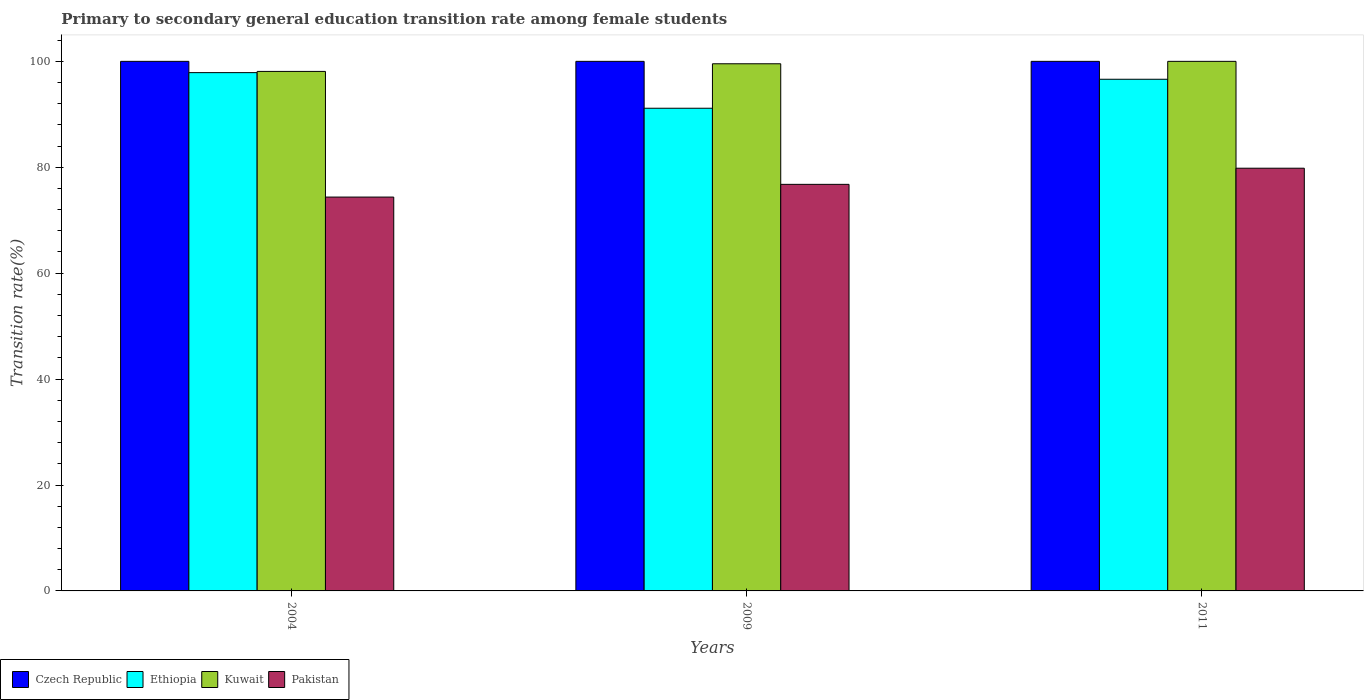How many groups of bars are there?
Keep it short and to the point. 3. Are the number of bars per tick equal to the number of legend labels?
Make the answer very short. Yes. Are the number of bars on each tick of the X-axis equal?
Provide a succinct answer. Yes. How many bars are there on the 1st tick from the left?
Keep it short and to the point. 4. How many bars are there on the 1st tick from the right?
Offer a terse response. 4. What is the label of the 1st group of bars from the left?
Offer a very short reply. 2004. What is the transition rate in Kuwait in 2004?
Ensure brevity in your answer.  98.1. Across all years, what is the maximum transition rate in Czech Republic?
Your response must be concise. 100. Across all years, what is the minimum transition rate in Ethiopia?
Your answer should be very brief. 91.15. In which year was the transition rate in Pakistan maximum?
Provide a succinct answer. 2011. In which year was the transition rate in Czech Republic minimum?
Offer a very short reply. 2004. What is the total transition rate in Pakistan in the graph?
Make the answer very short. 230.97. What is the difference between the transition rate in Ethiopia in 2004 and that in 2009?
Your answer should be very brief. 6.72. What is the difference between the transition rate in Ethiopia in 2011 and the transition rate in Czech Republic in 2009?
Offer a terse response. -3.38. What is the average transition rate in Pakistan per year?
Your response must be concise. 76.99. In the year 2011, what is the difference between the transition rate in Pakistan and transition rate in Kuwait?
Keep it short and to the point. -20.18. What is the ratio of the transition rate in Kuwait in 2009 to that in 2011?
Provide a succinct answer. 1. Is the transition rate in Ethiopia in 2009 less than that in 2011?
Give a very brief answer. Yes. Is the difference between the transition rate in Pakistan in 2009 and 2011 greater than the difference between the transition rate in Kuwait in 2009 and 2011?
Make the answer very short. No. What is the difference between the highest and the second highest transition rate in Ethiopia?
Your answer should be compact. 1.25. What is the difference between the highest and the lowest transition rate in Kuwait?
Your answer should be compact. 1.9. Is it the case that in every year, the sum of the transition rate in Ethiopia and transition rate in Pakistan is greater than the sum of transition rate in Czech Republic and transition rate in Kuwait?
Offer a very short reply. No. What does the 3rd bar from the right in 2004 represents?
Your response must be concise. Ethiopia. How many bars are there?
Your answer should be very brief. 12. Are all the bars in the graph horizontal?
Provide a succinct answer. No. How many years are there in the graph?
Make the answer very short. 3. What is the difference between two consecutive major ticks on the Y-axis?
Offer a terse response. 20. How many legend labels are there?
Keep it short and to the point. 4. What is the title of the graph?
Offer a very short reply. Primary to secondary general education transition rate among female students. Does "Serbia" appear as one of the legend labels in the graph?
Give a very brief answer. No. What is the label or title of the Y-axis?
Provide a short and direct response. Transition rate(%). What is the Transition rate(%) in Czech Republic in 2004?
Your response must be concise. 100. What is the Transition rate(%) of Ethiopia in 2004?
Your answer should be compact. 97.87. What is the Transition rate(%) in Kuwait in 2004?
Your response must be concise. 98.1. What is the Transition rate(%) in Pakistan in 2004?
Your response must be concise. 74.37. What is the Transition rate(%) of Ethiopia in 2009?
Your response must be concise. 91.15. What is the Transition rate(%) of Kuwait in 2009?
Ensure brevity in your answer.  99.54. What is the Transition rate(%) in Pakistan in 2009?
Your answer should be compact. 76.77. What is the Transition rate(%) of Czech Republic in 2011?
Offer a very short reply. 100. What is the Transition rate(%) in Ethiopia in 2011?
Your answer should be very brief. 96.62. What is the Transition rate(%) of Pakistan in 2011?
Ensure brevity in your answer.  79.82. Across all years, what is the maximum Transition rate(%) of Ethiopia?
Give a very brief answer. 97.87. Across all years, what is the maximum Transition rate(%) of Pakistan?
Provide a short and direct response. 79.82. Across all years, what is the minimum Transition rate(%) of Ethiopia?
Offer a very short reply. 91.15. Across all years, what is the minimum Transition rate(%) of Kuwait?
Make the answer very short. 98.1. Across all years, what is the minimum Transition rate(%) of Pakistan?
Offer a very short reply. 74.37. What is the total Transition rate(%) in Czech Republic in the graph?
Provide a succinct answer. 300. What is the total Transition rate(%) in Ethiopia in the graph?
Make the answer very short. 285.63. What is the total Transition rate(%) of Kuwait in the graph?
Ensure brevity in your answer.  297.64. What is the total Transition rate(%) of Pakistan in the graph?
Provide a short and direct response. 230.97. What is the difference between the Transition rate(%) of Czech Republic in 2004 and that in 2009?
Provide a short and direct response. 0. What is the difference between the Transition rate(%) in Ethiopia in 2004 and that in 2009?
Ensure brevity in your answer.  6.72. What is the difference between the Transition rate(%) of Kuwait in 2004 and that in 2009?
Offer a terse response. -1.44. What is the difference between the Transition rate(%) of Pakistan in 2004 and that in 2009?
Offer a very short reply. -2.4. What is the difference between the Transition rate(%) of Czech Republic in 2004 and that in 2011?
Provide a short and direct response. 0. What is the difference between the Transition rate(%) in Ethiopia in 2004 and that in 2011?
Provide a short and direct response. 1.25. What is the difference between the Transition rate(%) in Kuwait in 2004 and that in 2011?
Make the answer very short. -1.9. What is the difference between the Transition rate(%) of Pakistan in 2004 and that in 2011?
Provide a short and direct response. -5.45. What is the difference between the Transition rate(%) of Czech Republic in 2009 and that in 2011?
Provide a succinct answer. 0. What is the difference between the Transition rate(%) in Ethiopia in 2009 and that in 2011?
Keep it short and to the point. -5.47. What is the difference between the Transition rate(%) in Kuwait in 2009 and that in 2011?
Your answer should be compact. -0.46. What is the difference between the Transition rate(%) in Pakistan in 2009 and that in 2011?
Give a very brief answer. -3.05. What is the difference between the Transition rate(%) in Czech Republic in 2004 and the Transition rate(%) in Ethiopia in 2009?
Give a very brief answer. 8.85. What is the difference between the Transition rate(%) in Czech Republic in 2004 and the Transition rate(%) in Kuwait in 2009?
Keep it short and to the point. 0.46. What is the difference between the Transition rate(%) of Czech Republic in 2004 and the Transition rate(%) of Pakistan in 2009?
Make the answer very short. 23.23. What is the difference between the Transition rate(%) of Ethiopia in 2004 and the Transition rate(%) of Kuwait in 2009?
Provide a succinct answer. -1.67. What is the difference between the Transition rate(%) in Ethiopia in 2004 and the Transition rate(%) in Pakistan in 2009?
Provide a short and direct response. 21.1. What is the difference between the Transition rate(%) in Kuwait in 2004 and the Transition rate(%) in Pakistan in 2009?
Give a very brief answer. 21.33. What is the difference between the Transition rate(%) of Czech Republic in 2004 and the Transition rate(%) of Ethiopia in 2011?
Provide a succinct answer. 3.38. What is the difference between the Transition rate(%) in Czech Republic in 2004 and the Transition rate(%) in Pakistan in 2011?
Your answer should be compact. 20.18. What is the difference between the Transition rate(%) of Ethiopia in 2004 and the Transition rate(%) of Kuwait in 2011?
Give a very brief answer. -2.13. What is the difference between the Transition rate(%) in Ethiopia in 2004 and the Transition rate(%) in Pakistan in 2011?
Your answer should be very brief. 18.05. What is the difference between the Transition rate(%) of Kuwait in 2004 and the Transition rate(%) of Pakistan in 2011?
Provide a short and direct response. 18.28. What is the difference between the Transition rate(%) in Czech Republic in 2009 and the Transition rate(%) in Ethiopia in 2011?
Provide a succinct answer. 3.38. What is the difference between the Transition rate(%) in Czech Republic in 2009 and the Transition rate(%) in Pakistan in 2011?
Keep it short and to the point. 20.18. What is the difference between the Transition rate(%) in Ethiopia in 2009 and the Transition rate(%) in Kuwait in 2011?
Make the answer very short. -8.85. What is the difference between the Transition rate(%) in Ethiopia in 2009 and the Transition rate(%) in Pakistan in 2011?
Make the answer very short. 11.32. What is the difference between the Transition rate(%) in Kuwait in 2009 and the Transition rate(%) in Pakistan in 2011?
Provide a short and direct response. 19.72. What is the average Transition rate(%) of Czech Republic per year?
Offer a very short reply. 100. What is the average Transition rate(%) of Ethiopia per year?
Your answer should be compact. 95.21. What is the average Transition rate(%) of Kuwait per year?
Your response must be concise. 99.22. What is the average Transition rate(%) of Pakistan per year?
Your response must be concise. 76.99. In the year 2004, what is the difference between the Transition rate(%) in Czech Republic and Transition rate(%) in Ethiopia?
Your response must be concise. 2.13. In the year 2004, what is the difference between the Transition rate(%) in Czech Republic and Transition rate(%) in Kuwait?
Make the answer very short. 1.9. In the year 2004, what is the difference between the Transition rate(%) of Czech Republic and Transition rate(%) of Pakistan?
Give a very brief answer. 25.63. In the year 2004, what is the difference between the Transition rate(%) in Ethiopia and Transition rate(%) in Kuwait?
Your response must be concise. -0.23. In the year 2004, what is the difference between the Transition rate(%) in Ethiopia and Transition rate(%) in Pakistan?
Offer a terse response. 23.5. In the year 2004, what is the difference between the Transition rate(%) in Kuwait and Transition rate(%) in Pakistan?
Make the answer very short. 23.73. In the year 2009, what is the difference between the Transition rate(%) of Czech Republic and Transition rate(%) of Ethiopia?
Offer a terse response. 8.85. In the year 2009, what is the difference between the Transition rate(%) of Czech Republic and Transition rate(%) of Kuwait?
Offer a terse response. 0.46. In the year 2009, what is the difference between the Transition rate(%) of Czech Republic and Transition rate(%) of Pakistan?
Provide a short and direct response. 23.23. In the year 2009, what is the difference between the Transition rate(%) of Ethiopia and Transition rate(%) of Kuwait?
Provide a succinct answer. -8.4. In the year 2009, what is the difference between the Transition rate(%) in Ethiopia and Transition rate(%) in Pakistan?
Provide a short and direct response. 14.37. In the year 2009, what is the difference between the Transition rate(%) of Kuwait and Transition rate(%) of Pakistan?
Ensure brevity in your answer.  22.77. In the year 2011, what is the difference between the Transition rate(%) of Czech Republic and Transition rate(%) of Ethiopia?
Give a very brief answer. 3.38. In the year 2011, what is the difference between the Transition rate(%) of Czech Republic and Transition rate(%) of Pakistan?
Your answer should be compact. 20.18. In the year 2011, what is the difference between the Transition rate(%) of Ethiopia and Transition rate(%) of Kuwait?
Your answer should be very brief. -3.38. In the year 2011, what is the difference between the Transition rate(%) in Ethiopia and Transition rate(%) in Pakistan?
Provide a short and direct response. 16.8. In the year 2011, what is the difference between the Transition rate(%) in Kuwait and Transition rate(%) in Pakistan?
Ensure brevity in your answer.  20.18. What is the ratio of the Transition rate(%) in Czech Republic in 2004 to that in 2009?
Your answer should be compact. 1. What is the ratio of the Transition rate(%) of Ethiopia in 2004 to that in 2009?
Your answer should be very brief. 1.07. What is the ratio of the Transition rate(%) of Kuwait in 2004 to that in 2009?
Provide a succinct answer. 0.99. What is the ratio of the Transition rate(%) in Pakistan in 2004 to that in 2009?
Offer a very short reply. 0.97. What is the ratio of the Transition rate(%) in Ethiopia in 2004 to that in 2011?
Give a very brief answer. 1.01. What is the ratio of the Transition rate(%) in Pakistan in 2004 to that in 2011?
Offer a terse response. 0.93. What is the ratio of the Transition rate(%) of Ethiopia in 2009 to that in 2011?
Your answer should be very brief. 0.94. What is the ratio of the Transition rate(%) of Kuwait in 2009 to that in 2011?
Ensure brevity in your answer.  1. What is the ratio of the Transition rate(%) in Pakistan in 2009 to that in 2011?
Offer a very short reply. 0.96. What is the difference between the highest and the second highest Transition rate(%) of Czech Republic?
Make the answer very short. 0. What is the difference between the highest and the second highest Transition rate(%) in Ethiopia?
Your answer should be compact. 1.25. What is the difference between the highest and the second highest Transition rate(%) in Kuwait?
Offer a terse response. 0.46. What is the difference between the highest and the second highest Transition rate(%) of Pakistan?
Your answer should be compact. 3.05. What is the difference between the highest and the lowest Transition rate(%) in Ethiopia?
Ensure brevity in your answer.  6.72. What is the difference between the highest and the lowest Transition rate(%) of Kuwait?
Your response must be concise. 1.9. What is the difference between the highest and the lowest Transition rate(%) in Pakistan?
Provide a succinct answer. 5.45. 